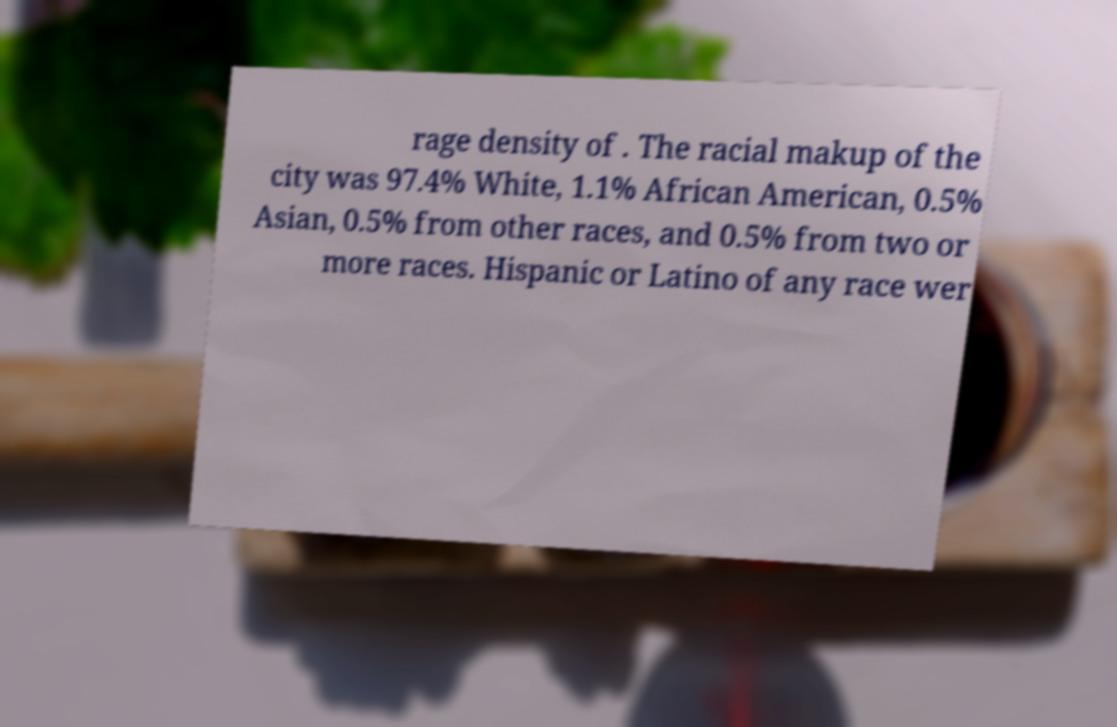What messages or text are displayed in this image? I need them in a readable, typed format. rage density of . The racial makup of the city was 97.4% White, 1.1% African American, 0.5% Asian, 0.5% from other races, and 0.5% from two or more races. Hispanic or Latino of any race wer 